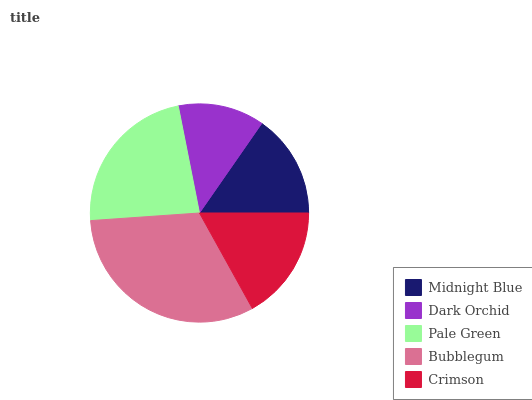Is Dark Orchid the minimum?
Answer yes or no. Yes. Is Bubblegum the maximum?
Answer yes or no. Yes. Is Pale Green the minimum?
Answer yes or no. No. Is Pale Green the maximum?
Answer yes or no. No. Is Pale Green greater than Dark Orchid?
Answer yes or no. Yes. Is Dark Orchid less than Pale Green?
Answer yes or no. Yes. Is Dark Orchid greater than Pale Green?
Answer yes or no. No. Is Pale Green less than Dark Orchid?
Answer yes or no. No. Is Crimson the high median?
Answer yes or no. Yes. Is Crimson the low median?
Answer yes or no. Yes. Is Bubblegum the high median?
Answer yes or no. No. Is Bubblegum the low median?
Answer yes or no. No. 